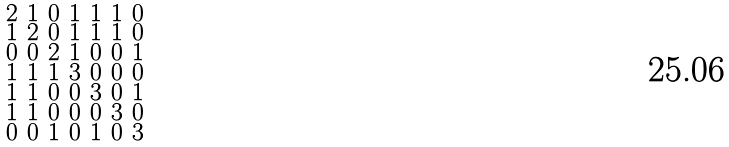Convert formula to latex. <formula><loc_0><loc_0><loc_500><loc_500>\begin{smallmatrix} 2 & 1 & 0 & 1 & 1 & 1 & 0 \\ 1 & 2 & 0 & 1 & 1 & 1 & 0 \\ 0 & 0 & 2 & 1 & 0 & 0 & 1 \\ 1 & 1 & 1 & 3 & 0 & 0 & 0 \\ 1 & 1 & 0 & 0 & 3 & 0 & 1 \\ 1 & 1 & 0 & 0 & 0 & 3 & 0 \\ 0 & 0 & 1 & 0 & 1 & 0 & 3 \end{smallmatrix}</formula> 